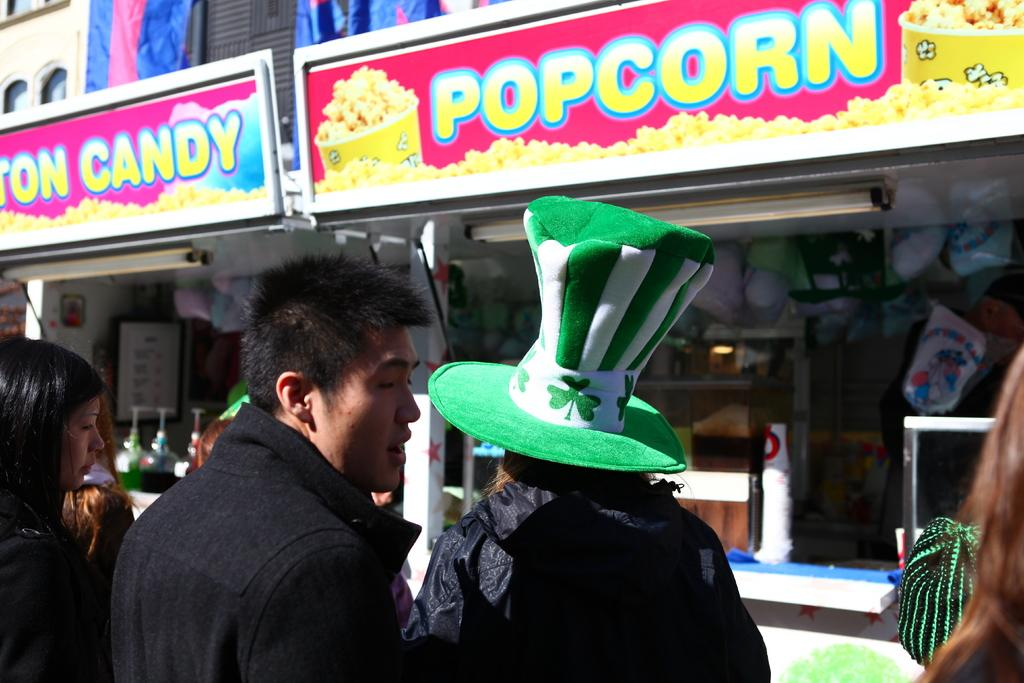What is happening in the center of the image? There are people standing in the center of the image. Can you describe the appearance of one of the individuals? There is a lady wearing a cap. What can be seen in the background of the image? There are stores and a building in the background of the image. What type of comb is the lady using to brush her hair in the image? There is no comb visible in the image, nor is there any indication that the lady is brushing her hair. 